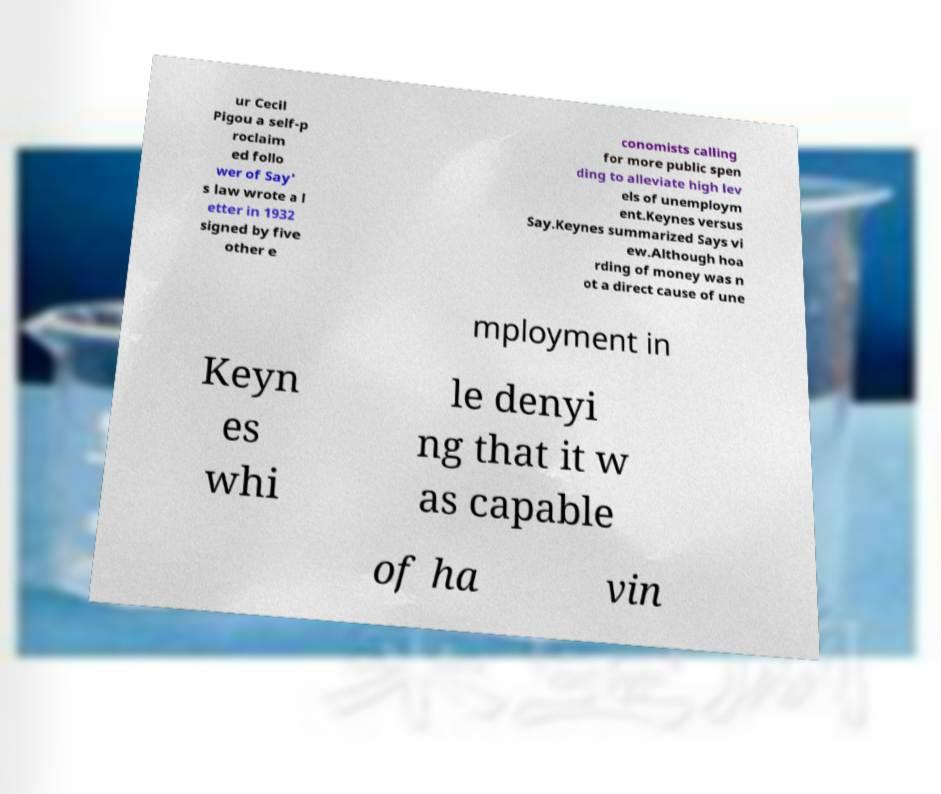Please identify and transcribe the text found in this image. ur Cecil Pigou a self-p roclaim ed follo wer of Say' s law wrote a l etter in 1932 signed by five other e conomists calling for more public spen ding to alleviate high lev els of unemploym ent.Keynes versus Say.Keynes summarized Says vi ew.Although hoa rding of money was n ot a direct cause of une mployment in Keyn es whi le denyi ng that it w as capable of ha vin 